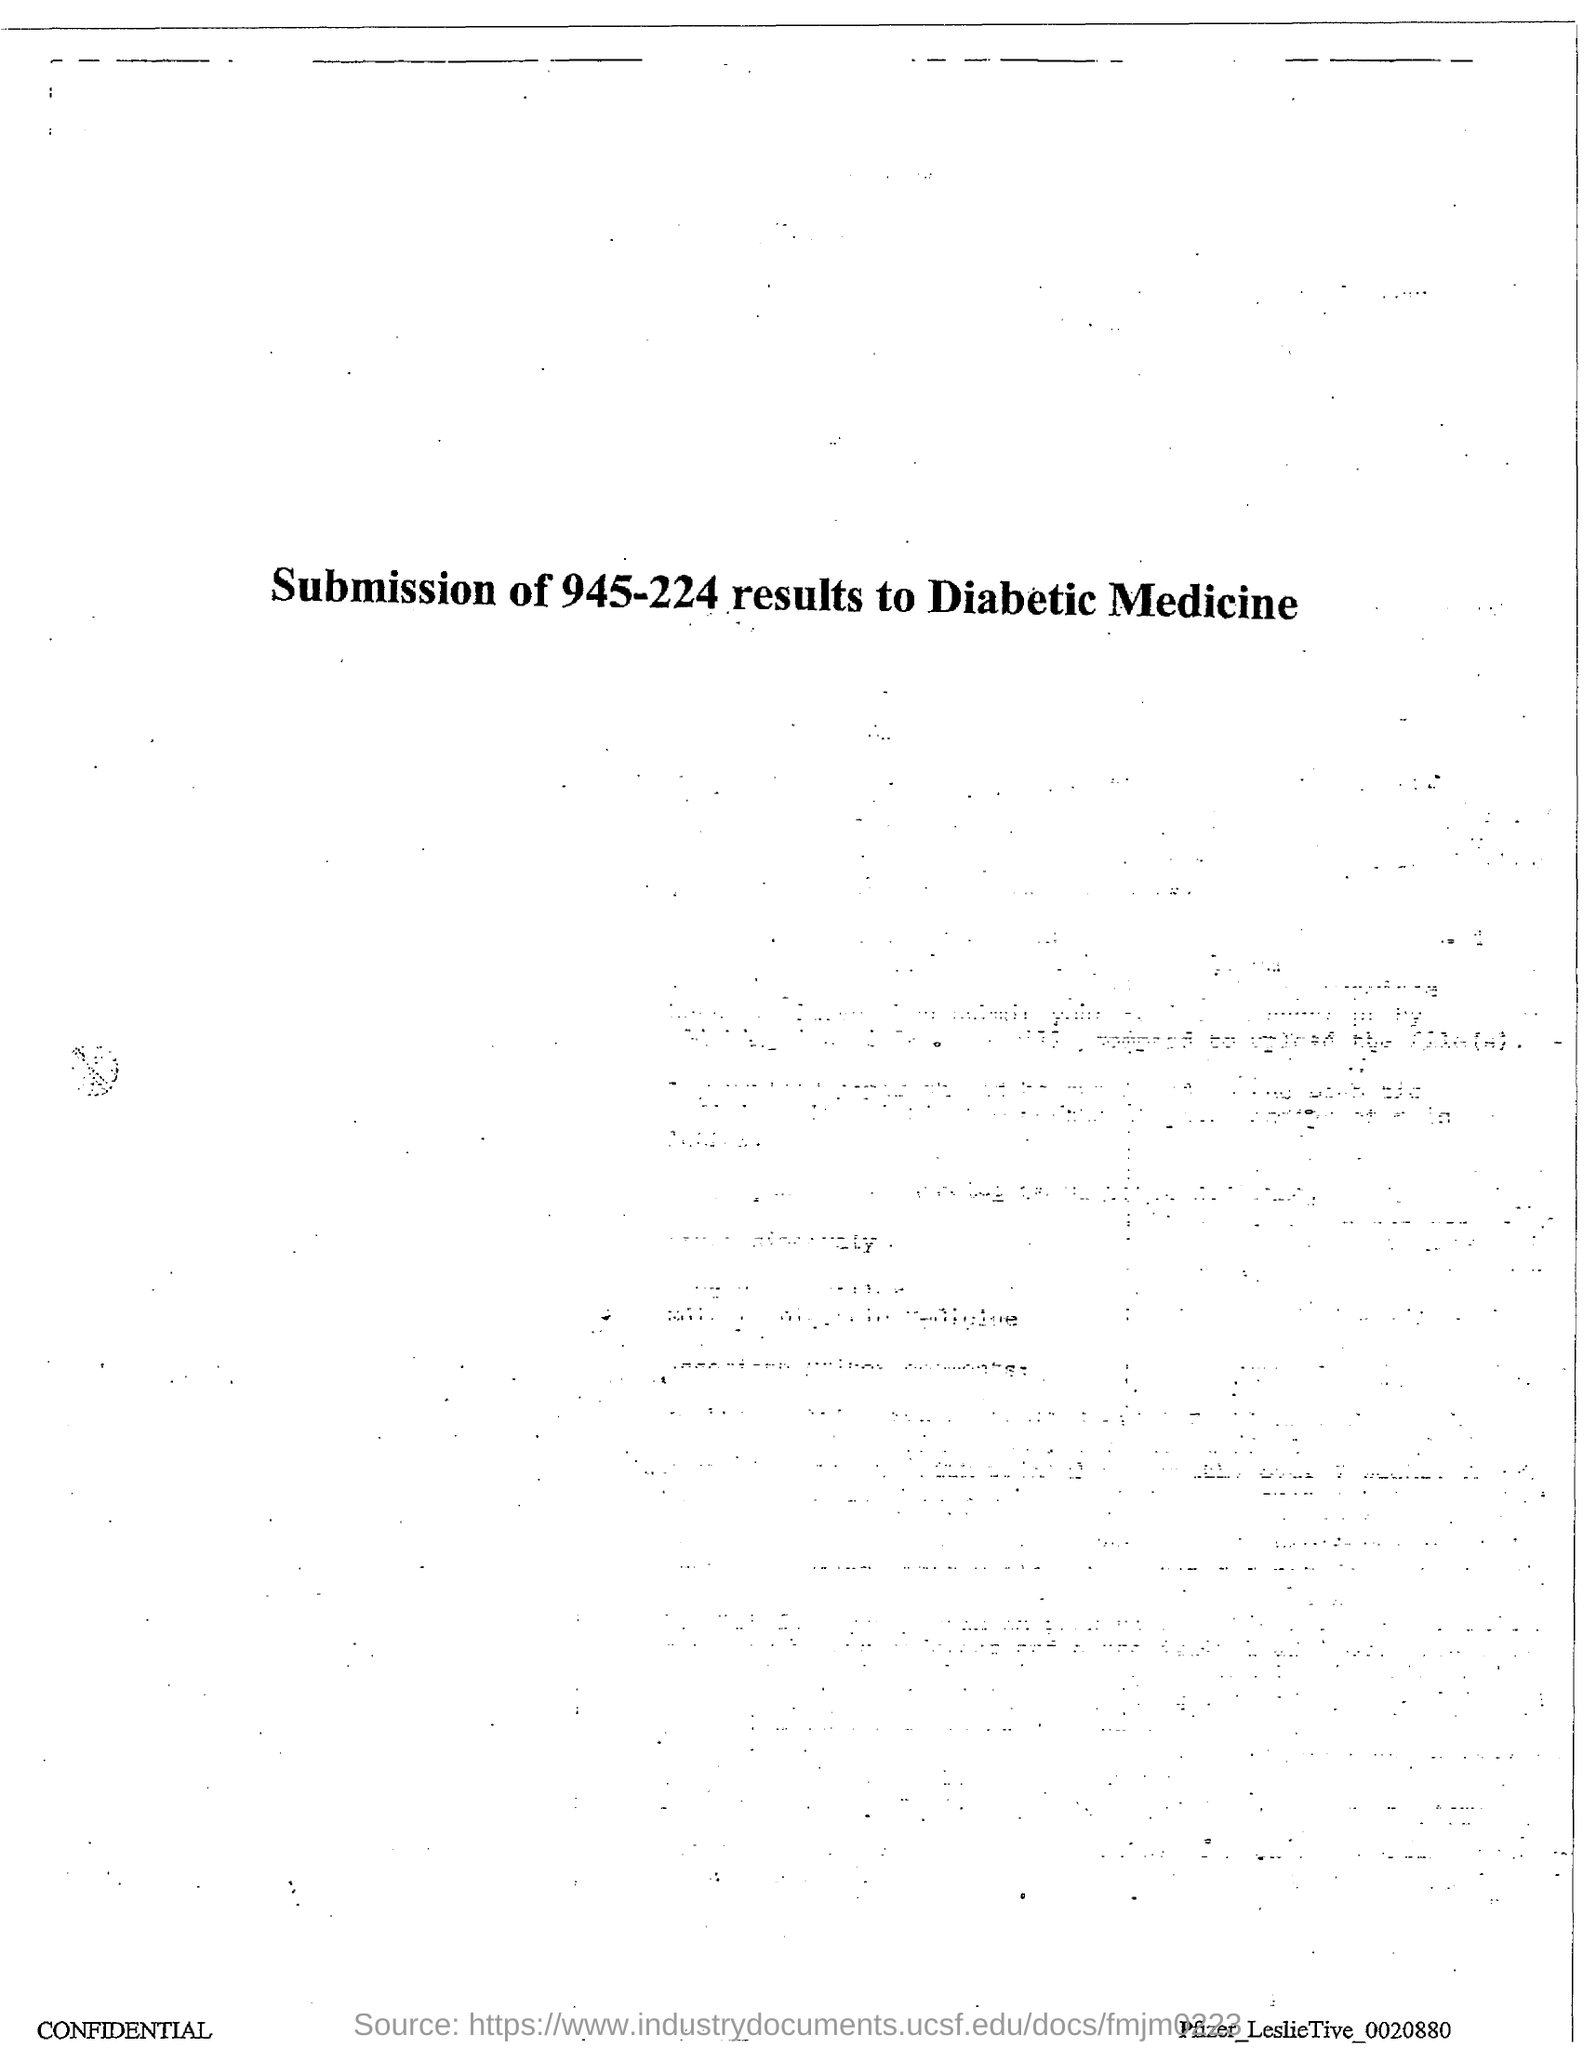What is the title of the document?
Provide a succinct answer. Submission of 945-224 results to diabetic medicine. 